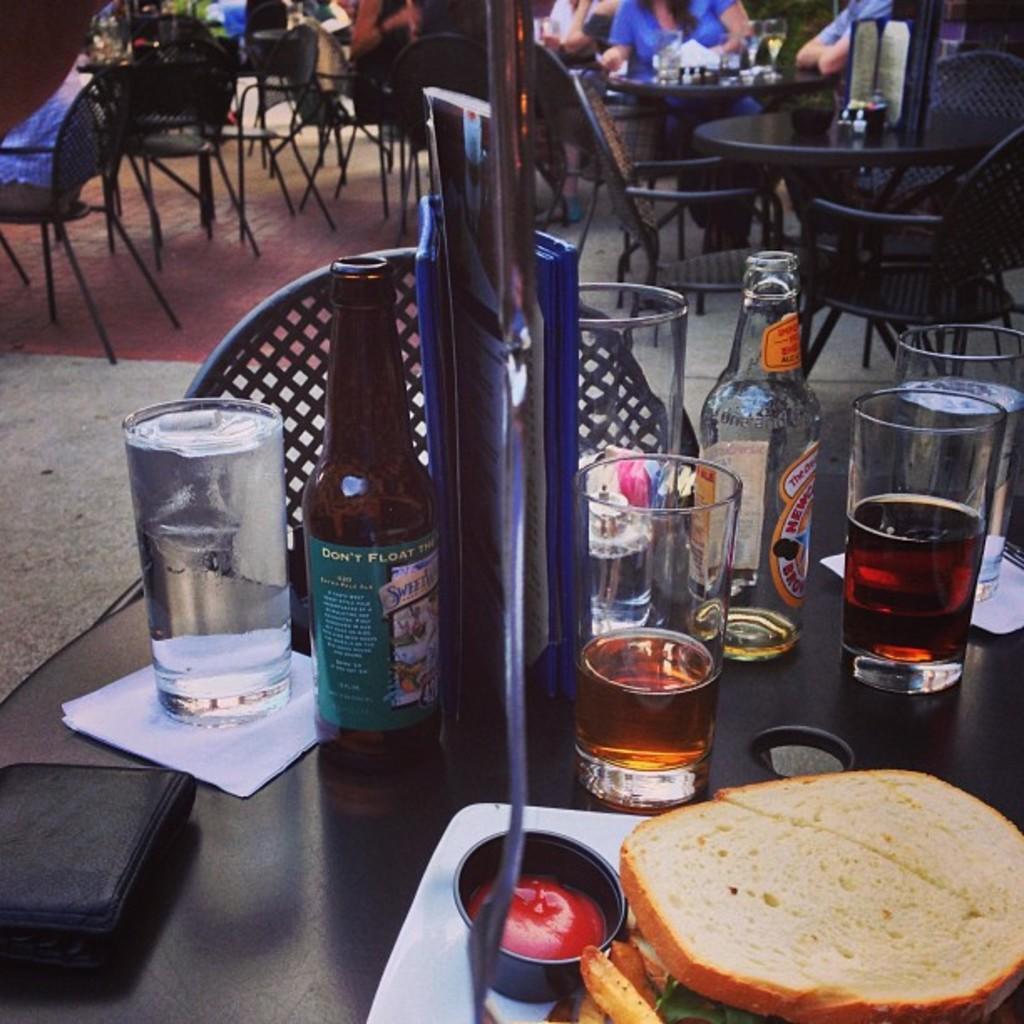Please provide a concise description of this image. In this image I can see number of glasses and bottles on this table. In the background I can see few more chairs and tables. Also I can see few people. 